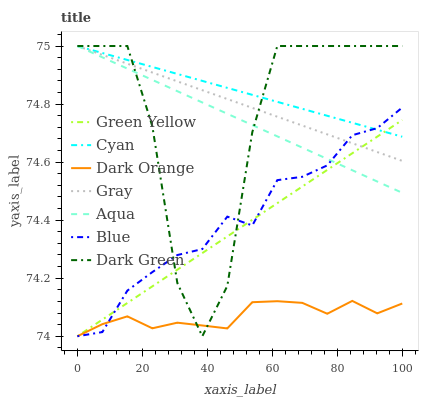Does Dark Orange have the minimum area under the curve?
Answer yes or no. Yes. Does Cyan have the maximum area under the curve?
Answer yes or no. Yes. Does Gray have the minimum area under the curve?
Answer yes or no. No. Does Gray have the maximum area under the curve?
Answer yes or no. No. Is Gray the smoothest?
Answer yes or no. Yes. Is Dark Green the roughest?
Answer yes or no. Yes. Is Dark Orange the smoothest?
Answer yes or no. No. Is Dark Orange the roughest?
Answer yes or no. No. Does Blue have the lowest value?
Answer yes or no. Yes. Does Gray have the lowest value?
Answer yes or no. No. Does Dark Green have the highest value?
Answer yes or no. Yes. Does Dark Orange have the highest value?
Answer yes or no. No. Is Dark Orange less than Cyan?
Answer yes or no. Yes. Is Gray greater than Dark Orange?
Answer yes or no. Yes. Does Blue intersect Dark Green?
Answer yes or no. Yes. Is Blue less than Dark Green?
Answer yes or no. No. Is Blue greater than Dark Green?
Answer yes or no. No. Does Dark Orange intersect Cyan?
Answer yes or no. No. 